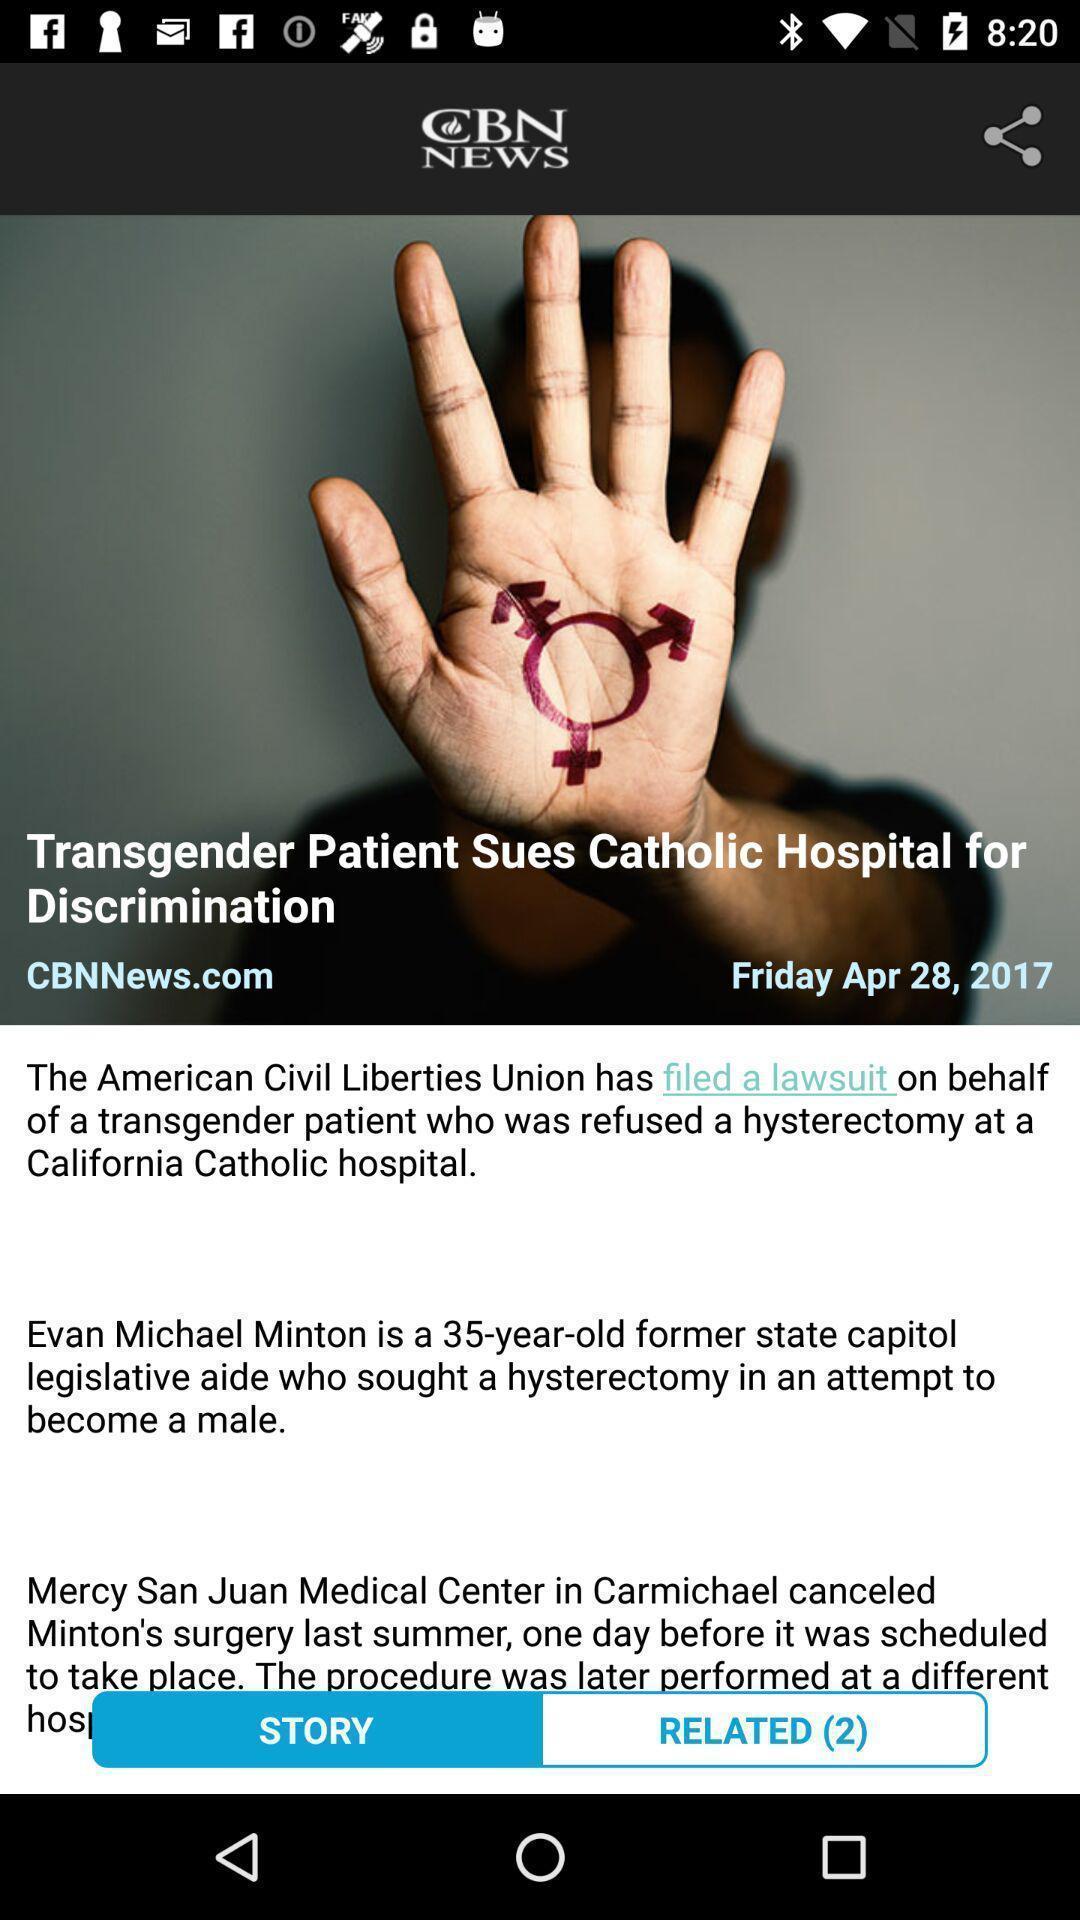Tell me what you see in this picture. Screen showing news. 